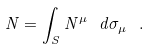<formula> <loc_0><loc_0><loc_500><loc_500>N = \int _ { S } N ^ { \mu } \ d \sigma _ { \mu } \ .</formula> 